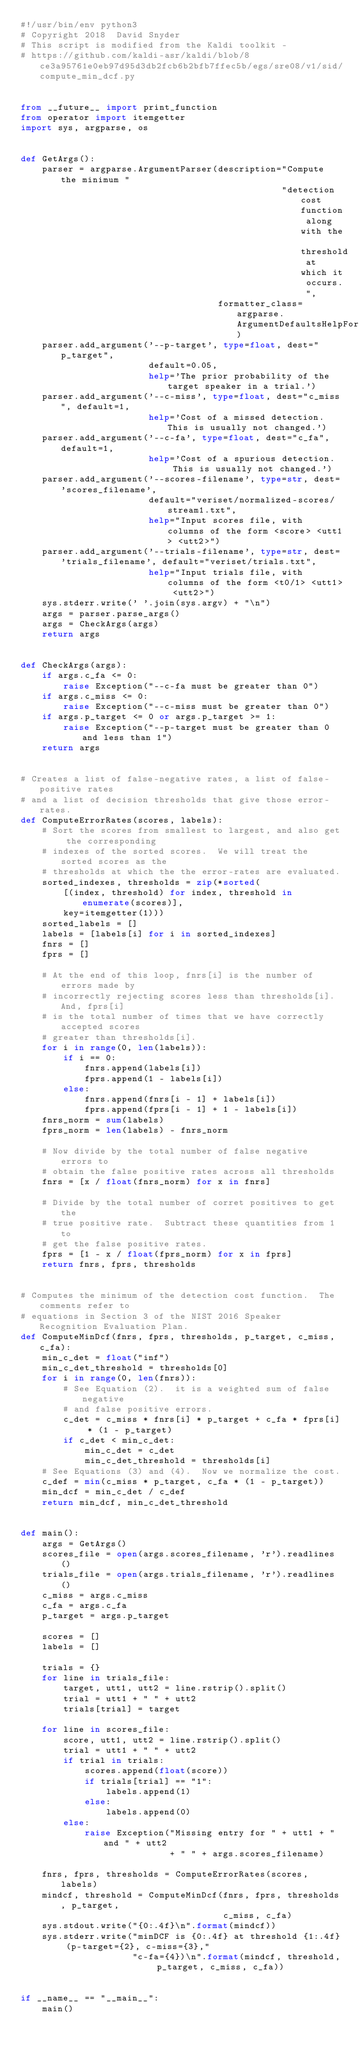Convert code to text. <code><loc_0><loc_0><loc_500><loc_500><_Python_>#!/usr/bin/env python3
# Copyright 2018  David Snyder
# This script is modified from the Kaldi toolkit -
# https://github.com/kaldi-asr/kaldi/blob/8ce3a95761e0eb97d95d3db2fcb6b2bfb7ffec5b/egs/sre08/v1/sid/compute_min_dcf.py


from __future__ import print_function
from operator import itemgetter
import sys, argparse, os


def GetArgs():
    parser = argparse.ArgumentParser(description="Compute the minimum "
                                                 "detection cost function along with the threshold at which it occurs. ",
                                     formatter_class=argparse.ArgumentDefaultsHelpFormatter)
    parser.add_argument('--p-target', type=float, dest="p_target",
                        default=0.05,
                        help='The prior probability of the target speaker in a trial.')
    parser.add_argument('--c-miss', type=float, dest="c_miss", default=1,
                        help='Cost of a missed detection.  This is usually not changed.')
    parser.add_argument('--c-fa', type=float, dest="c_fa", default=1,
                        help='Cost of a spurious detection.  This is usually not changed.')
    parser.add_argument('--scores-filename', type=str, dest='scores_filename',
                        default="veriset/normalized-scores/stream1.txt",
                        help="Input scores file, with columns of the form <score> <utt1> <utt2>")
    parser.add_argument('--trials-filename', type=str, dest='trials_filename', default="veriset/trials.txt",
                        help="Input trials file, with columns of the form <t0/1> <utt1> <utt2>")
    sys.stderr.write(' '.join(sys.argv) + "\n")
    args = parser.parse_args()
    args = CheckArgs(args)
    return args


def CheckArgs(args):
    if args.c_fa <= 0:
        raise Exception("--c-fa must be greater than 0")
    if args.c_miss <= 0:
        raise Exception("--c-miss must be greater than 0")
    if args.p_target <= 0 or args.p_target >= 1:
        raise Exception("--p-target must be greater than 0 and less than 1")
    return args


# Creates a list of false-negative rates, a list of false-positive rates
# and a list of decision thresholds that give those error-rates.
def ComputeErrorRates(scores, labels):
    # Sort the scores from smallest to largest, and also get the corresponding
    # indexes of the sorted scores.  We will treat the sorted scores as the
    # thresholds at which the the error-rates are evaluated.
    sorted_indexes, thresholds = zip(*sorted(
        [(index, threshold) for index, threshold in enumerate(scores)],
        key=itemgetter(1)))
    sorted_labels = []
    labels = [labels[i] for i in sorted_indexes]
    fnrs = []
    fprs = []

    # At the end of this loop, fnrs[i] is the number of errors made by
    # incorrectly rejecting scores less than thresholds[i]. And, fprs[i]
    # is the total number of times that we have correctly accepted scores
    # greater than thresholds[i].
    for i in range(0, len(labels)):
        if i == 0:
            fnrs.append(labels[i])
            fprs.append(1 - labels[i])
        else:
            fnrs.append(fnrs[i - 1] + labels[i])
            fprs.append(fprs[i - 1] + 1 - labels[i])
    fnrs_norm = sum(labels)
    fprs_norm = len(labels) - fnrs_norm

    # Now divide by the total number of false negative errors to
    # obtain the false positive rates across all thresholds
    fnrs = [x / float(fnrs_norm) for x in fnrs]

    # Divide by the total number of corret positives to get the
    # true positive rate.  Subtract these quantities from 1 to
    # get the false positive rates.
    fprs = [1 - x / float(fprs_norm) for x in fprs]
    return fnrs, fprs, thresholds


# Computes the minimum of the detection cost function.  The comments refer to
# equations in Section 3 of the NIST 2016 Speaker Recognition Evaluation Plan.
def ComputeMinDcf(fnrs, fprs, thresholds, p_target, c_miss, c_fa):
    min_c_det = float("inf")
    min_c_det_threshold = thresholds[0]
    for i in range(0, len(fnrs)):
        # See Equation (2).  it is a weighted sum of false negative
        # and false positive errors.
        c_det = c_miss * fnrs[i] * p_target + c_fa * fprs[i] * (1 - p_target)
        if c_det < min_c_det:
            min_c_det = c_det
            min_c_det_threshold = thresholds[i]
    # See Equations (3) and (4).  Now we normalize the cost.
    c_def = min(c_miss * p_target, c_fa * (1 - p_target))
    min_dcf = min_c_det / c_def
    return min_dcf, min_c_det_threshold


def main():
    args = GetArgs()
    scores_file = open(args.scores_filename, 'r').readlines()
    trials_file = open(args.trials_filename, 'r').readlines()
    c_miss = args.c_miss
    c_fa = args.c_fa
    p_target = args.p_target

    scores = []
    labels = []

    trials = {}
    for line in trials_file:
        target, utt1, utt2 = line.rstrip().split()
        trial = utt1 + " " + utt2
        trials[trial] = target

    for line in scores_file:
        score, utt1, utt2 = line.rstrip().split()
        trial = utt1 + " " + utt2
        if trial in trials:
            scores.append(float(score))
            if trials[trial] == "1":
                labels.append(1)
            else:
                labels.append(0)
        else:
            raise Exception("Missing entry for " + utt1 + " and " + utt2
                            + " " + args.scores_filename)

    fnrs, fprs, thresholds = ComputeErrorRates(scores, labels)
    mindcf, threshold = ComputeMinDcf(fnrs, fprs, thresholds, p_target,
                                      c_miss, c_fa)
    sys.stdout.write("{0:.4f}\n".format(mindcf))
    sys.stderr.write("minDCF is {0:.4f} at threshold {1:.4f} (p-target={2}, c-miss={3},"
                     "c-fa={4})\n".format(mindcf, threshold, p_target, c_miss, c_fa))


if __name__ == "__main__":
    main()
</code> 